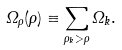Convert formula to latex. <formula><loc_0><loc_0><loc_500><loc_500>\Omega _ { \rho } ( \rho ) \equiv \sum _ { \rho _ { k } > \rho } \Omega _ { k } .</formula> 